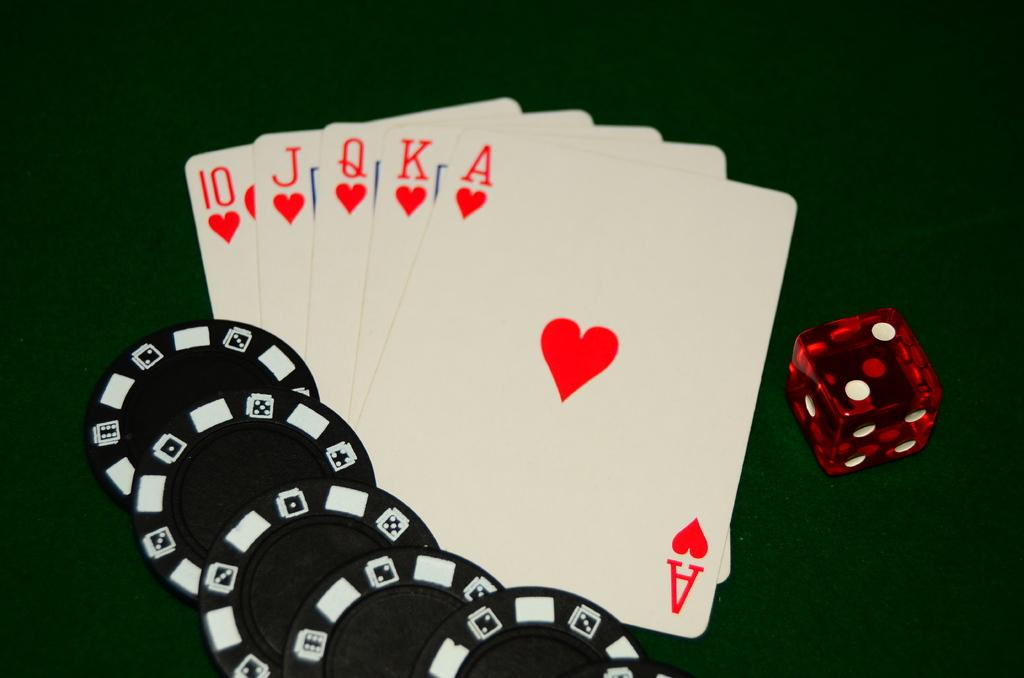<image>
Describe the image concisely. Five black poker chips, a red die, and five playing cards showing a royal flush are all next to each other. 